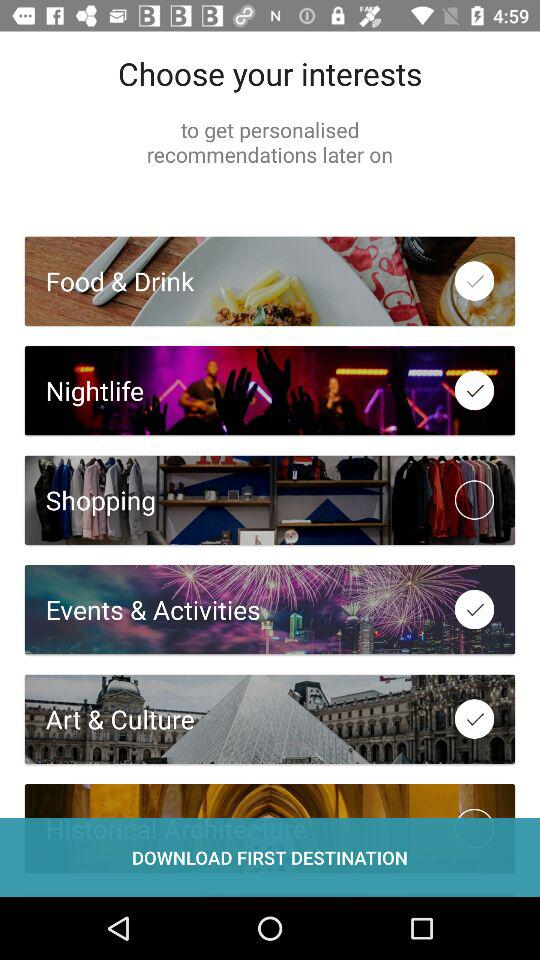Which choices were selected? The selected options were "Food & Drink", "Nightlife", "Events & Activities" and "Art & Culture". 